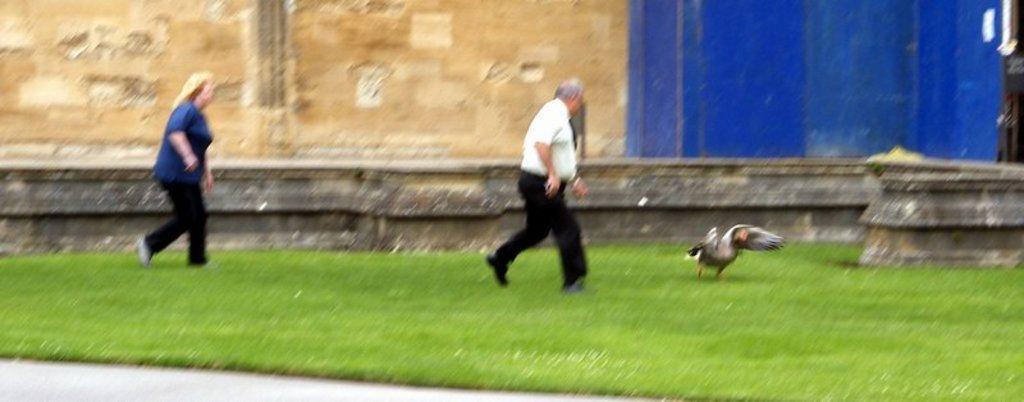How would you summarize this image in a sentence or two? This is an outside view. Here I can see the grass on the ground. On the right side there is a bird. There are two persons running towards the bird. In the background there is a wall. In the bottom left-hand corner there is a road. 